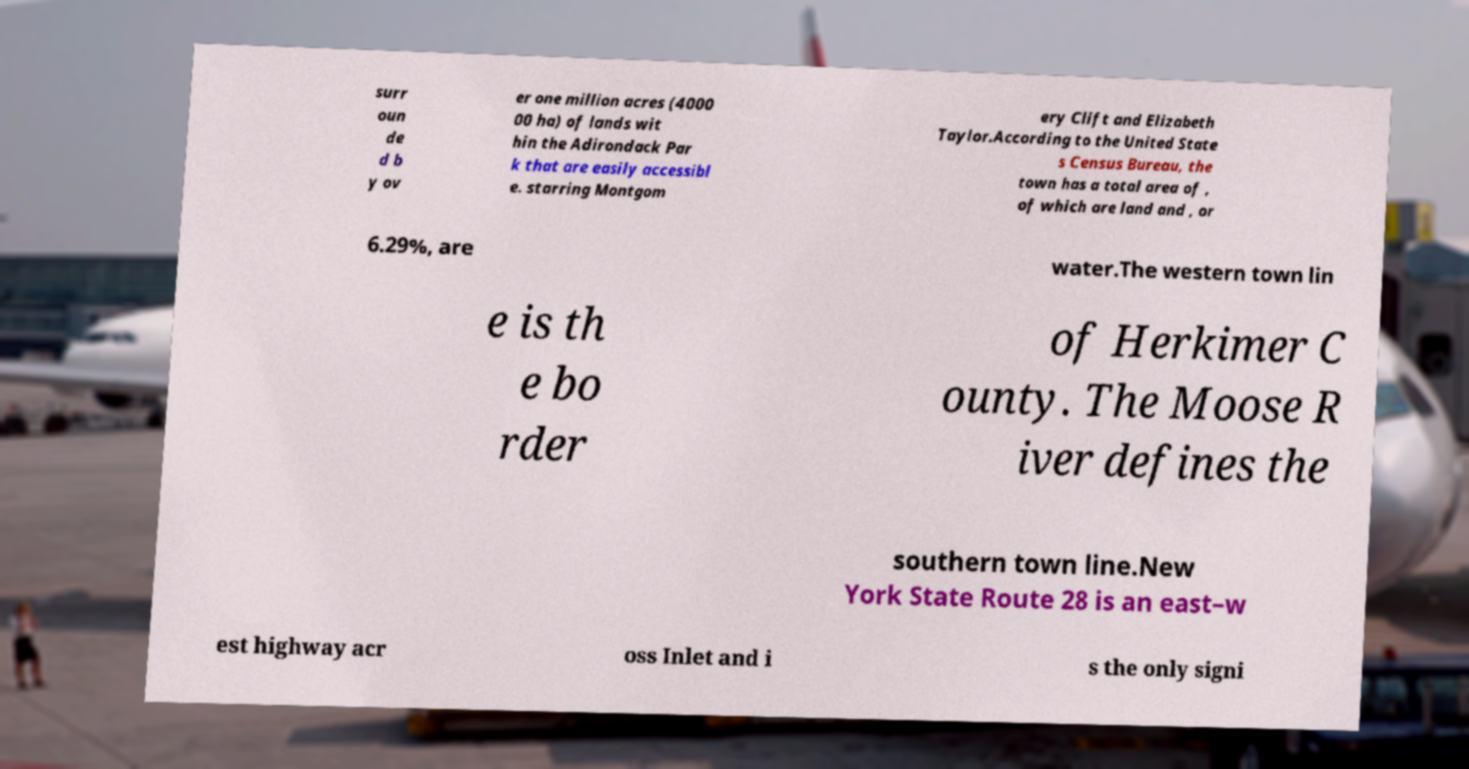Could you extract and type out the text from this image? surr oun de d b y ov er one million acres (4000 00 ha) of lands wit hin the Adirondack Par k that are easily accessibl e. starring Montgom ery Clift and Elizabeth Taylor.According to the United State s Census Bureau, the town has a total area of , of which are land and , or 6.29%, are water.The western town lin e is th e bo rder of Herkimer C ounty. The Moose R iver defines the southern town line.New York State Route 28 is an east–w est highway acr oss Inlet and i s the only signi 